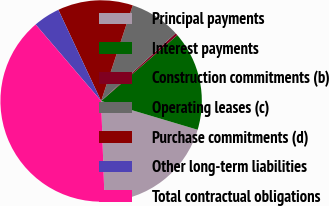Convert chart. <chart><loc_0><loc_0><loc_500><loc_500><pie_chart><fcel>Principal payments<fcel>Interest payments<fcel>Construction commitments (b)<fcel>Operating leases (c)<fcel>Purchase commitments (d)<fcel>Other long-term liabilities<fcel>Total contractual obligations<nl><fcel>19.84%<fcel>15.95%<fcel>0.4%<fcel>8.18%<fcel>12.06%<fcel>4.29%<fcel>39.28%<nl></chart> 